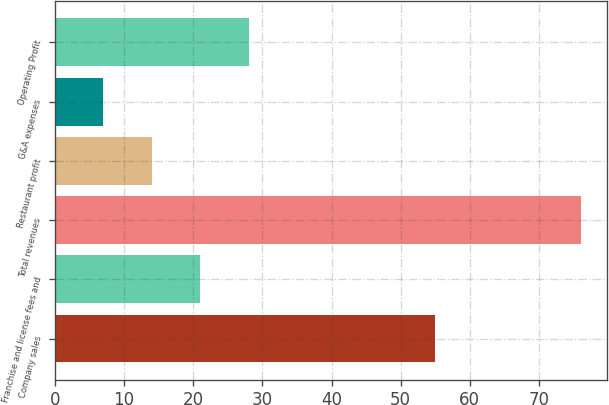Convert chart to OTSL. <chart><loc_0><loc_0><loc_500><loc_500><bar_chart><fcel>Company sales<fcel>Franchise and license fees and<fcel>Total revenues<fcel>Restaurant profit<fcel>G&A expenses<fcel>Operating Profit<nl><fcel>55<fcel>21<fcel>76<fcel>14<fcel>7<fcel>28<nl></chart> 